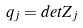Convert formula to latex. <formula><loc_0><loc_0><loc_500><loc_500>q _ { j } = d e t Z _ { j }</formula> 